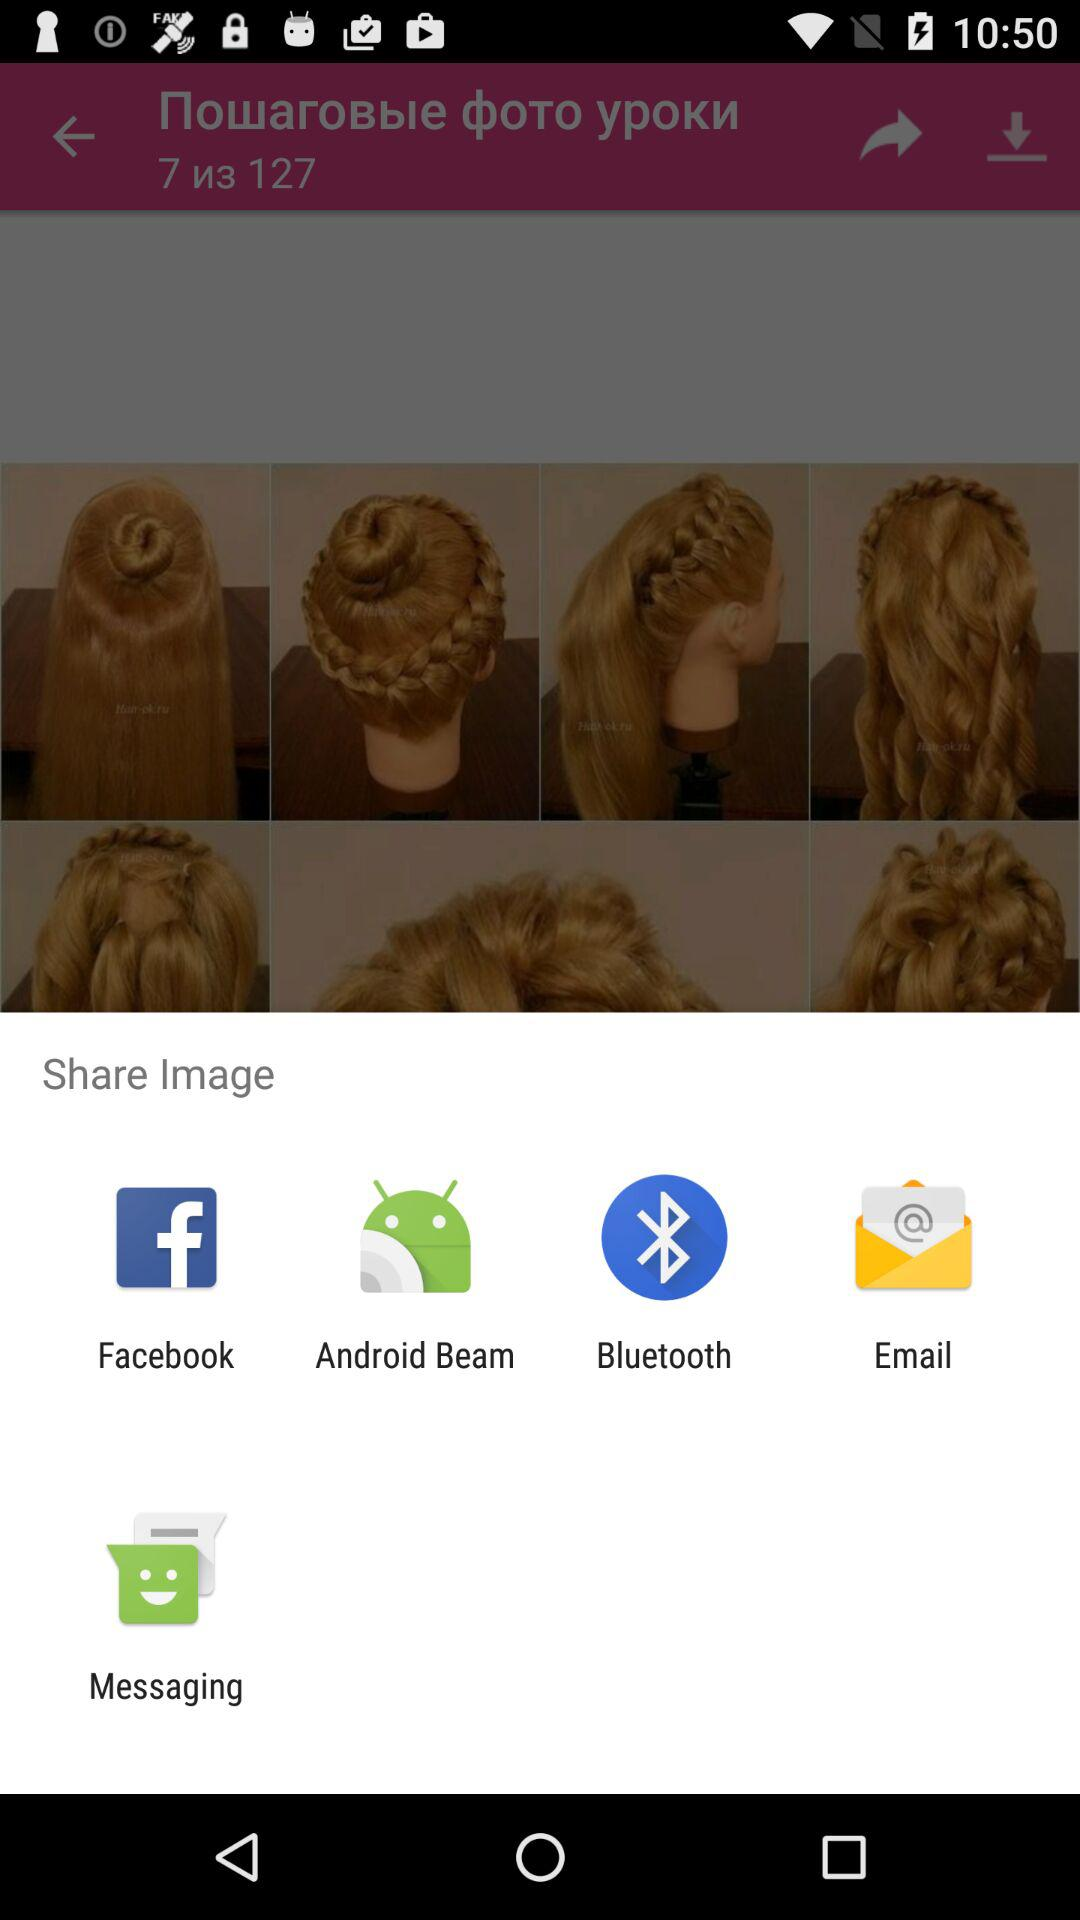Where will the file be saved to?
When the provided information is insufficient, respond with <no answer>. <no answer> 